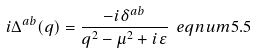<formula> <loc_0><loc_0><loc_500><loc_500>i \Delta ^ { a b } ( q ) = \frac { - i \delta ^ { a b } } { q ^ { 2 } - \mu ^ { 2 } + i \varepsilon } \ e q n u m { 5 . 5 }</formula> 